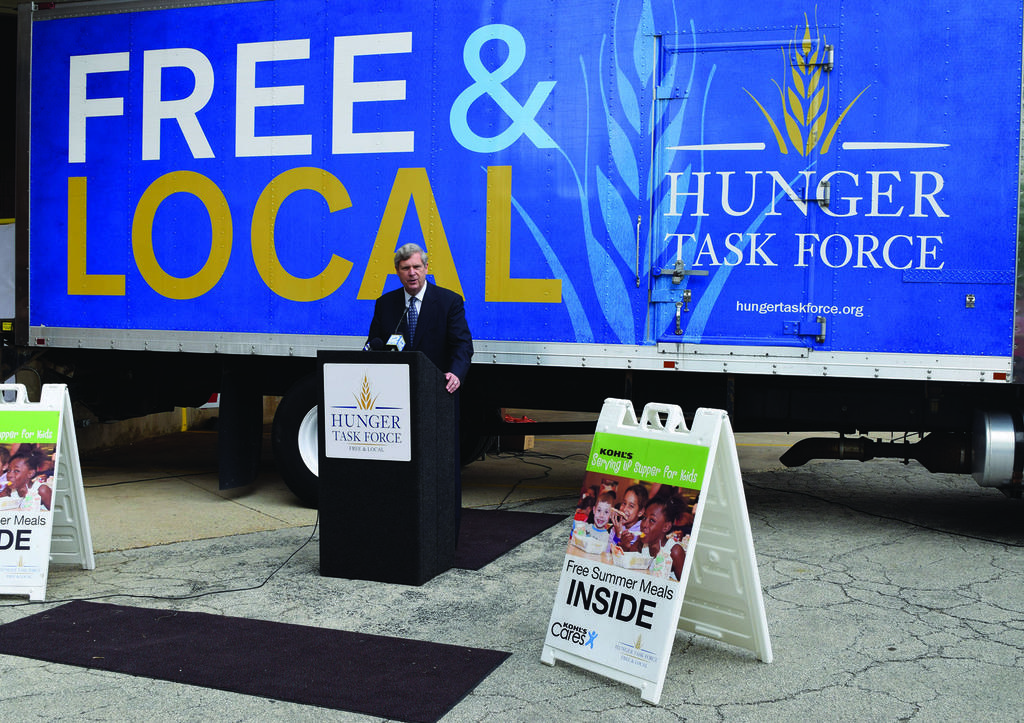What type of force is this?
Your response must be concise. Hunger task force. 